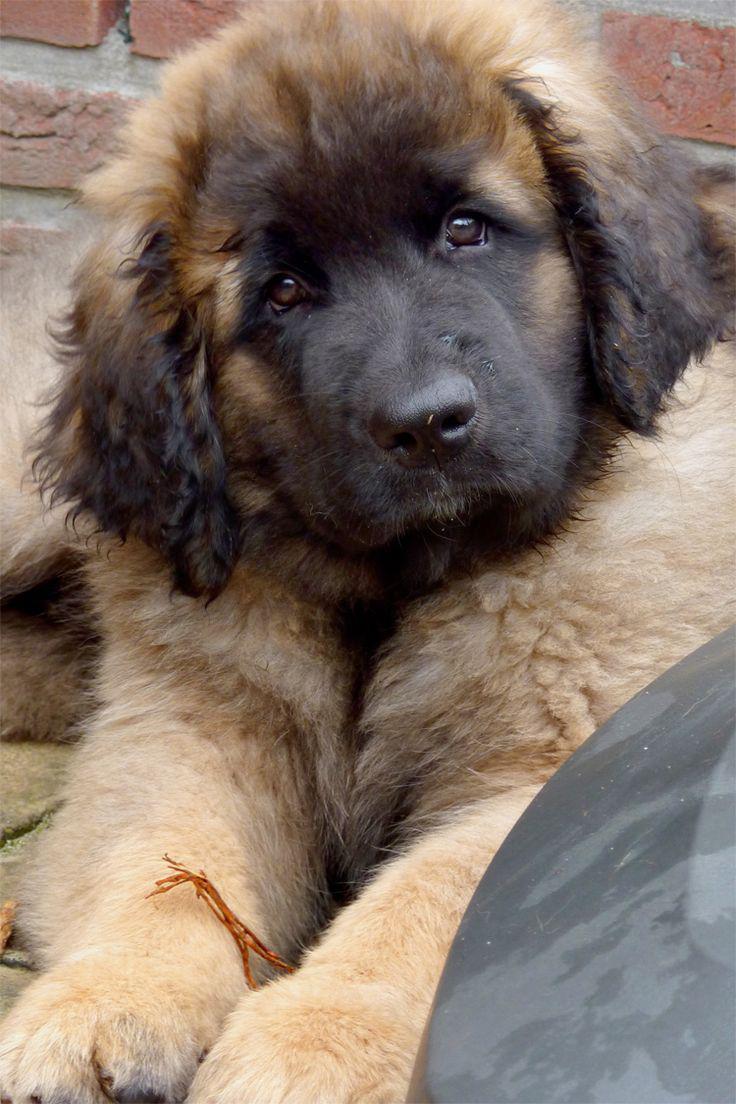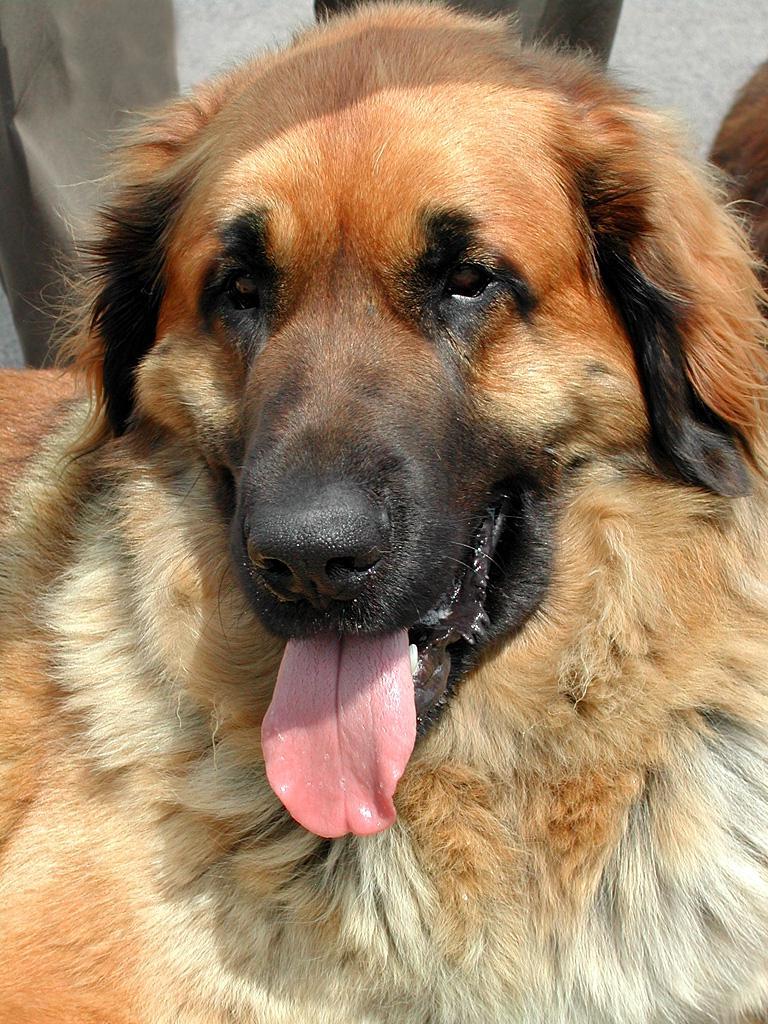The first image is the image on the left, the second image is the image on the right. For the images shown, is this caption "At least one of the dogs in an image is not alone." true? Answer yes or no. No. The first image is the image on the left, the second image is the image on the right. Assess this claim about the two images: "A dogs". Correct or not? Answer yes or no. No. 